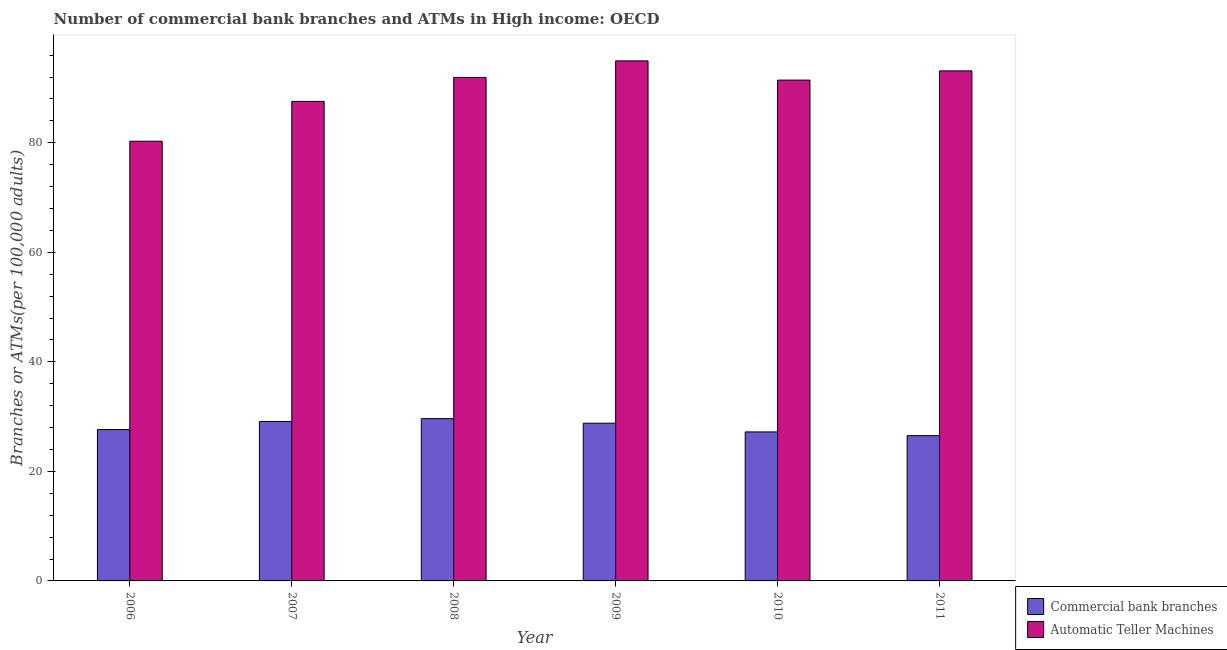How many bars are there on the 5th tick from the left?
Give a very brief answer. 2. What is the label of the 5th group of bars from the left?
Ensure brevity in your answer.  2010. In how many cases, is the number of bars for a given year not equal to the number of legend labels?
Offer a terse response. 0. What is the number of commercal bank branches in 2010?
Your answer should be compact. 27.21. Across all years, what is the maximum number of atms?
Your response must be concise. 94.95. Across all years, what is the minimum number of atms?
Give a very brief answer. 80.28. In which year was the number of commercal bank branches maximum?
Ensure brevity in your answer.  2008. What is the total number of atms in the graph?
Make the answer very short. 539.25. What is the difference between the number of atms in 2008 and that in 2009?
Your answer should be very brief. -3.03. What is the difference between the number of commercal bank branches in 2010 and the number of atms in 2007?
Ensure brevity in your answer.  -1.91. What is the average number of commercal bank branches per year?
Your answer should be very brief. 28.15. In the year 2010, what is the difference between the number of commercal bank branches and number of atms?
Provide a succinct answer. 0. What is the ratio of the number of atms in 2007 to that in 2010?
Offer a terse response. 0.96. What is the difference between the highest and the second highest number of commercal bank branches?
Provide a short and direct response. 0.52. What is the difference between the highest and the lowest number of atms?
Your answer should be very brief. 14.67. In how many years, is the number of commercal bank branches greater than the average number of commercal bank branches taken over all years?
Offer a very short reply. 3. What does the 1st bar from the left in 2007 represents?
Your response must be concise. Commercial bank branches. What does the 1st bar from the right in 2007 represents?
Keep it short and to the point. Automatic Teller Machines. How many bars are there?
Give a very brief answer. 12. Does the graph contain grids?
Keep it short and to the point. No. How are the legend labels stacked?
Keep it short and to the point. Vertical. What is the title of the graph?
Give a very brief answer. Number of commercial bank branches and ATMs in High income: OECD. What is the label or title of the Y-axis?
Your answer should be compact. Branches or ATMs(per 100,0 adults). What is the Branches or ATMs(per 100,000 adults) of Commercial bank branches in 2006?
Your answer should be very brief. 27.63. What is the Branches or ATMs(per 100,000 adults) in Automatic Teller Machines in 2006?
Provide a short and direct response. 80.28. What is the Branches or ATMs(per 100,000 adults) in Commercial bank branches in 2007?
Keep it short and to the point. 29.11. What is the Branches or ATMs(per 100,000 adults) in Automatic Teller Machines in 2007?
Offer a very short reply. 87.55. What is the Branches or ATMs(per 100,000 adults) of Commercial bank branches in 2008?
Provide a short and direct response. 29.63. What is the Branches or ATMs(per 100,000 adults) in Automatic Teller Machines in 2008?
Offer a very short reply. 91.92. What is the Branches or ATMs(per 100,000 adults) in Commercial bank branches in 2009?
Provide a succinct answer. 28.79. What is the Branches or ATMs(per 100,000 adults) of Automatic Teller Machines in 2009?
Make the answer very short. 94.95. What is the Branches or ATMs(per 100,000 adults) in Commercial bank branches in 2010?
Offer a very short reply. 27.21. What is the Branches or ATMs(per 100,000 adults) of Automatic Teller Machines in 2010?
Keep it short and to the point. 91.44. What is the Branches or ATMs(per 100,000 adults) in Commercial bank branches in 2011?
Keep it short and to the point. 26.53. What is the Branches or ATMs(per 100,000 adults) in Automatic Teller Machines in 2011?
Make the answer very short. 93.12. Across all years, what is the maximum Branches or ATMs(per 100,000 adults) of Commercial bank branches?
Provide a short and direct response. 29.63. Across all years, what is the maximum Branches or ATMs(per 100,000 adults) of Automatic Teller Machines?
Offer a terse response. 94.95. Across all years, what is the minimum Branches or ATMs(per 100,000 adults) in Commercial bank branches?
Provide a short and direct response. 26.53. Across all years, what is the minimum Branches or ATMs(per 100,000 adults) of Automatic Teller Machines?
Offer a terse response. 80.28. What is the total Branches or ATMs(per 100,000 adults) of Commercial bank branches in the graph?
Offer a terse response. 168.91. What is the total Branches or ATMs(per 100,000 adults) in Automatic Teller Machines in the graph?
Ensure brevity in your answer.  539.25. What is the difference between the Branches or ATMs(per 100,000 adults) of Commercial bank branches in 2006 and that in 2007?
Give a very brief answer. -1.48. What is the difference between the Branches or ATMs(per 100,000 adults) in Automatic Teller Machines in 2006 and that in 2007?
Provide a short and direct response. -7.27. What is the difference between the Branches or ATMs(per 100,000 adults) in Commercial bank branches in 2006 and that in 2008?
Provide a succinct answer. -2. What is the difference between the Branches or ATMs(per 100,000 adults) of Automatic Teller Machines in 2006 and that in 2008?
Provide a short and direct response. -11.64. What is the difference between the Branches or ATMs(per 100,000 adults) in Commercial bank branches in 2006 and that in 2009?
Give a very brief answer. -1.16. What is the difference between the Branches or ATMs(per 100,000 adults) of Automatic Teller Machines in 2006 and that in 2009?
Your response must be concise. -14.67. What is the difference between the Branches or ATMs(per 100,000 adults) in Commercial bank branches in 2006 and that in 2010?
Make the answer very short. 0.43. What is the difference between the Branches or ATMs(per 100,000 adults) in Automatic Teller Machines in 2006 and that in 2010?
Your answer should be very brief. -11.16. What is the difference between the Branches or ATMs(per 100,000 adults) in Commercial bank branches in 2006 and that in 2011?
Your answer should be very brief. 1.11. What is the difference between the Branches or ATMs(per 100,000 adults) in Automatic Teller Machines in 2006 and that in 2011?
Ensure brevity in your answer.  -12.84. What is the difference between the Branches or ATMs(per 100,000 adults) of Commercial bank branches in 2007 and that in 2008?
Your answer should be very brief. -0.52. What is the difference between the Branches or ATMs(per 100,000 adults) in Automatic Teller Machines in 2007 and that in 2008?
Your answer should be compact. -4.37. What is the difference between the Branches or ATMs(per 100,000 adults) in Commercial bank branches in 2007 and that in 2009?
Ensure brevity in your answer.  0.32. What is the difference between the Branches or ATMs(per 100,000 adults) in Automatic Teller Machines in 2007 and that in 2009?
Provide a succinct answer. -7.4. What is the difference between the Branches or ATMs(per 100,000 adults) of Commercial bank branches in 2007 and that in 2010?
Your answer should be very brief. 1.91. What is the difference between the Branches or ATMs(per 100,000 adults) of Automatic Teller Machines in 2007 and that in 2010?
Your answer should be compact. -3.89. What is the difference between the Branches or ATMs(per 100,000 adults) in Commercial bank branches in 2007 and that in 2011?
Your response must be concise. 2.59. What is the difference between the Branches or ATMs(per 100,000 adults) in Automatic Teller Machines in 2007 and that in 2011?
Provide a short and direct response. -5.57. What is the difference between the Branches or ATMs(per 100,000 adults) in Commercial bank branches in 2008 and that in 2009?
Your answer should be compact. 0.84. What is the difference between the Branches or ATMs(per 100,000 adults) in Automatic Teller Machines in 2008 and that in 2009?
Your response must be concise. -3.03. What is the difference between the Branches or ATMs(per 100,000 adults) of Commercial bank branches in 2008 and that in 2010?
Provide a succinct answer. 2.43. What is the difference between the Branches or ATMs(per 100,000 adults) in Automatic Teller Machines in 2008 and that in 2010?
Make the answer very short. 0.48. What is the difference between the Branches or ATMs(per 100,000 adults) of Commercial bank branches in 2008 and that in 2011?
Provide a short and direct response. 3.11. What is the difference between the Branches or ATMs(per 100,000 adults) of Automatic Teller Machines in 2008 and that in 2011?
Provide a short and direct response. -1.2. What is the difference between the Branches or ATMs(per 100,000 adults) in Commercial bank branches in 2009 and that in 2010?
Provide a short and direct response. 1.59. What is the difference between the Branches or ATMs(per 100,000 adults) of Automatic Teller Machines in 2009 and that in 2010?
Offer a very short reply. 3.51. What is the difference between the Branches or ATMs(per 100,000 adults) of Commercial bank branches in 2009 and that in 2011?
Offer a terse response. 2.27. What is the difference between the Branches or ATMs(per 100,000 adults) of Automatic Teller Machines in 2009 and that in 2011?
Your answer should be compact. 1.83. What is the difference between the Branches or ATMs(per 100,000 adults) of Commercial bank branches in 2010 and that in 2011?
Ensure brevity in your answer.  0.68. What is the difference between the Branches or ATMs(per 100,000 adults) of Automatic Teller Machines in 2010 and that in 2011?
Provide a short and direct response. -1.68. What is the difference between the Branches or ATMs(per 100,000 adults) of Commercial bank branches in 2006 and the Branches or ATMs(per 100,000 adults) of Automatic Teller Machines in 2007?
Make the answer very short. -59.92. What is the difference between the Branches or ATMs(per 100,000 adults) of Commercial bank branches in 2006 and the Branches or ATMs(per 100,000 adults) of Automatic Teller Machines in 2008?
Provide a succinct answer. -64.29. What is the difference between the Branches or ATMs(per 100,000 adults) in Commercial bank branches in 2006 and the Branches or ATMs(per 100,000 adults) in Automatic Teller Machines in 2009?
Provide a succinct answer. -67.31. What is the difference between the Branches or ATMs(per 100,000 adults) in Commercial bank branches in 2006 and the Branches or ATMs(per 100,000 adults) in Automatic Teller Machines in 2010?
Provide a succinct answer. -63.8. What is the difference between the Branches or ATMs(per 100,000 adults) in Commercial bank branches in 2006 and the Branches or ATMs(per 100,000 adults) in Automatic Teller Machines in 2011?
Your response must be concise. -65.49. What is the difference between the Branches or ATMs(per 100,000 adults) in Commercial bank branches in 2007 and the Branches or ATMs(per 100,000 adults) in Automatic Teller Machines in 2008?
Ensure brevity in your answer.  -62.81. What is the difference between the Branches or ATMs(per 100,000 adults) in Commercial bank branches in 2007 and the Branches or ATMs(per 100,000 adults) in Automatic Teller Machines in 2009?
Provide a succinct answer. -65.83. What is the difference between the Branches or ATMs(per 100,000 adults) of Commercial bank branches in 2007 and the Branches or ATMs(per 100,000 adults) of Automatic Teller Machines in 2010?
Ensure brevity in your answer.  -62.32. What is the difference between the Branches or ATMs(per 100,000 adults) in Commercial bank branches in 2007 and the Branches or ATMs(per 100,000 adults) in Automatic Teller Machines in 2011?
Keep it short and to the point. -64. What is the difference between the Branches or ATMs(per 100,000 adults) of Commercial bank branches in 2008 and the Branches or ATMs(per 100,000 adults) of Automatic Teller Machines in 2009?
Offer a terse response. -65.31. What is the difference between the Branches or ATMs(per 100,000 adults) in Commercial bank branches in 2008 and the Branches or ATMs(per 100,000 adults) in Automatic Teller Machines in 2010?
Provide a succinct answer. -61.8. What is the difference between the Branches or ATMs(per 100,000 adults) of Commercial bank branches in 2008 and the Branches or ATMs(per 100,000 adults) of Automatic Teller Machines in 2011?
Provide a succinct answer. -63.48. What is the difference between the Branches or ATMs(per 100,000 adults) of Commercial bank branches in 2009 and the Branches or ATMs(per 100,000 adults) of Automatic Teller Machines in 2010?
Give a very brief answer. -62.64. What is the difference between the Branches or ATMs(per 100,000 adults) in Commercial bank branches in 2009 and the Branches or ATMs(per 100,000 adults) in Automatic Teller Machines in 2011?
Your response must be concise. -64.33. What is the difference between the Branches or ATMs(per 100,000 adults) of Commercial bank branches in 2010 and the Branches or ATMs(per 100,000 adults) of Automatic Teller Machines in 2011?
Offer a terse response. -65.91. What is the average Branches or ATMs(per 100,000 adults) of Commercial bank branches per year?
Provide a succinct answer. 28.15. What is the average Branches or ATMs(per 100,000 adults) of Automatic Teller Machines per year?
Keep it short and to the point. 89.87. In the year 2006, what is the difference between the Branches or ATMs(per 100,000 adults) of Commercial bank branches and Branches or ATMs(per 100,000 adults) of Automatic Teller Machines?
Provide a short and direct response. -52.65. In the year 2007, what is the difference between the Branches or ATMs(per 100,000 adults) of Commercial bank branches and Branches or ATMs(per 100,000 adults) of Automatic Teller Machines?
Provide a short and direct response. -58.43. In the year 2008, what is the difference between the Branches or ATMs(per 100,000 adults) in Commercial bank branches and Branches or ATMs(per 100,000 adults) in Automatic Teller Machines?
Your response must be concise. -62.29. In the year 2009, what is the difference between the Branches or ATMs(per 100,000 adults) in Commercial bank branches and Branches or ATMs(per 100,000 adults) in Automatic Teller Machines?
Your answer should be very brief. -66.15. In the year 2010, what is the difference between the Branches or ATMs(per 100,000 adults) in Commercial bank branches and Branches or ATMs(per 100,000 adults) in Automatic Teller Machines?
Make the answer very short. -64.23. In the year 2011, what is the difference between the Branches or ATMs(per 100,000 adults) in Commercial bank branches and Branches or ATMs(per 100,000 adults) in Automatic Teller Machines?
Offer a terse response. -66.59. What is the ratio of the Branches or ATMs(per 100,000 adults) of Commercial bank branches in 2006 to that in 2007?
Offer a very short reply. 0.95. What is the ratio of the Branches or ATMs(per 100,000 adults) in Automatic Teller Machines in 2006 to that in 2007?
Offer a terse response. 0.92. What is the ratio of the Branches or ATMs(per 100,000 adults) in Commercial bank branches in 2006 to that in 2008?
Provide a short and direct response. 0.93. What is the ratio of the Branches or ATMs(per 100,000 adults) of Automatic Teller Machines in 2006 to that in 2008?
Your answer should be compact. 0.87. What is the ratio of the Branches or ATMs(per 100,000 adults) in Commercial bank branches in 2006 to that in 2009?
Your answer should be compact. 0.96. What is the ratio of the Branches or ATMs(per 100,000 adults) of Automatic Teller Machines in 2006 to that in 2009?
Your answer should be very brief. 0.85. What is the ratio of the Branches or ATMs(per 100,000 adults) in Commercial bank branches in 2006 to that in 2010?
Give a very brief answer. 1.02. What is the ratio of the Branches or ATMs(per 100,000 adults) of Automatic Teller Machines in 2006 to that in 2010?
Provide a short and direct response. 0.88. What is the ratio of the Branches or ATMs(per 100,000 adults) of Commercial bank branches in 2006 to that in 2011?
Offer a terse response. 1.04. What is the ratio of the Branches or ATMs(per 100,000 adults) of Automatic Teller Machines in 2006 to that in 2011?
Make the answer very short. 0.86. What is the ratio of the Branches or ATMs(per 100,000 adults) of Commercial bank branches in 2007 to that in 2008?
Make the answer very short. 0.98. What is the ratio of the Branches or ATMs(per 100,000 adults) in Commercial bank branches in 2007 to that in 2009?
Offer a very short reply. 1.01. What is the ratio of the Branches or ATMs(per 100,000 adults) of Automatic Teller Machines in 2007 to that in 2009?
Offer a terse response. 0.92. What is the ratio of the Branches or ATMs(per 100,000 adults) in Commercial bank branches in 2007 to that in 2010?
Make the answer very short. 1.07. What is the ratio of the Branches or ATMs(per 100,000 adults) of Automatic Teller Machines in 2007 to that in 2010?
Offer a very short reply. 0.96. What is the ratio of the Branches or ATMs(per 100,000 adults) of Commercial bank branches in 2007 to that in 2011?
Give a very brief answer. 1.1. What is the ratio of the Branches or ATMs(per 100,000 adults) of Automatic Teller Machines in 2007 to that in 2011?
Your response must be concise. 0.94. What is the ratio of the Branches or ATMs(per 100,000 adults) in Commercial bank branches in 2008 to that in 2009?
Give a very brief answer. 1.03. What is the ratio of the Branches or ATMs(per 100,000 adults) in Automatic Teller Machines in 2008 to that in 2009?
Offer a terse response. 0.97. What is the ratio of the Branches or ATMs(per 100,000 adults) of Commercial bank branches in 2008 to that in 2010?
Ensure brevity in your answer.  1.09. What is the ratio of the Branches or ATMs(per 100,000 adults) of Automatic Teller Machines in 2008 to that in 2010?
Make the answer very short. 1.01. What is the ratio of the Branches or ATMs(per 100,000 adults) of Commercial bank branches in 2008 to that in 2011?
Provide a succinct answer. 1.12. What is the ratio of the Branches or ATMs(per 100,000 adults) in Automatic Teller Machines in 2008 to that in 2011?
Your answer should be compact. 0.99. What is the ratio of the Branches or ATMs(per 100,000 adults) in Commercial bank branches in 2009 to that in 2010?
Give a very brief answer. 1.06. What is the ratio of the Branches or ATMs(per 100,000 adults) of Automatic Teller Machines in 2009 to that in 2010?
Give a very brief answer. 1.04. What is the ratio of the Branches or ATMs(per 100,000 adults) in Commercial bank branches in 2009 to that in 2011?
Make the answer very short. 1.09. What is the ratio of the Branches or ATMs(per 100,000 adults) in Automatic Teller Machines in 2009 to that in 2011?
Your response must be concise. 1.02. What is the ratio of the Branches or ATMs(per 100,000 adults) in Commercial bank branches in 2010 to that in 2011?
Ensure brevity in your answer.  1.03. What is the ratio of the Branches or ATMs(per 100,000 adults) of Automatic Teller Machines in 2010 to that in 2011?
Keep it short and to the point. 0.98. What is the difference between the highest and the second highest Branches or ATMs(per 100,000 adults) of Commercial bank branches?
Your response must be concise. 0.52. What is the difference between the highest and the second highest Branches or ATMs(per 100,000 adults) in Automatic Teller Machines?
Give a very brief answer. 1.83. What is the difference between the highest and the lowest Branches or ATMs(per 100,000 adults) in Commercial bank branches?
Ensure brevity in your answer.  3.11. What is the difference between the highest and the lowest Branches or ATMs(per 100,000 adults) of Automatic Teller Machines?
Ensure brevity in your answer.  14.67. 